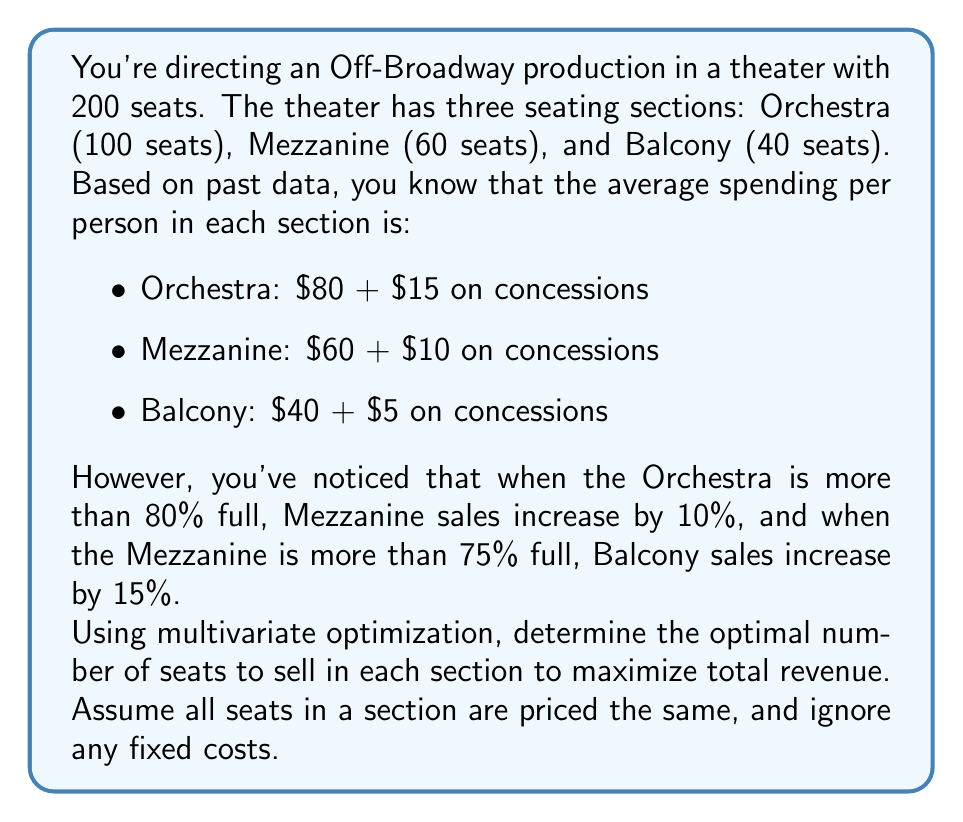Give your solution to this math problem. To solve this problem, we need to set up a multivariate optimization model. Let's define our variables:

$x$ = number of Orchestra seats sold
$y$ = number of Mezzanine seats sold
$z$ = number of Balcony seats sold

Our objective function to maximize revenue is:

$$R = 95x + 70y + 45z$$

Subject to the constraints:

1) $0 \leq x \leq 100$ (Orchestra capacity)
2) $0 \leq y \leq 60$ (Mezzanine capacity)
3) $0 \leq z \leq 40$ (Balcony capacity)

Now, we need to account for the conditional increases:

4) If $x > 80$, then $y$ increases by 10%
5) If $y > 45$, then $z$ increases by 15%

To incorporate these conditions, we can use piecewise functions:

$$R = 95x + 70y + 45z + 7I(x>80)y + 6.75I(y>45)z$$

Where $I()$ is the indicator function that equals 1 when the condition is true and 0 otherwise.

To solve this, we can use a numerical optimization method like gradient descent or a solver that can handle piecewise functions. However, given the small number of possibilities, we can also enumerate all possibilities:

1) Sell all Orchestra seats: $x=100$, $y=60$, $z=40$
   $R = 95(100) + 70(60) + 45(40) + 7(60) + 6.75(40) = 14,990$

2) Sell 80 Orchestra seats: $x=80$, $y=60$, $z=40$
   $R = 95(80) + 70(60) + 45(40) + 6.75(40) = 13,070$

3) Sell all Orchestra and Mezzanine seats: $x=100$, $y=60$, $z=40$
   $R = 95(100) + 70(60) + 45(40) + 7(60) + 6.75(40) = 14,990$

4) Sell 80 Orchestra and 45 Mezzanine seats: $x=80$, $y=45$, $z=40$
   $R = 95(80) + 70(45) + 45(40) = 11,950$

The maximum revenue is achieved when all seats are sold and both conditional increases are triggered.
Answer: The optimal seating arrangement for maximum revenue is to sell all seats: 100 Orchestra seats, 60 Mezzanine seats, and 40 Balcony seats. This results in a total revenue of $14,990. 